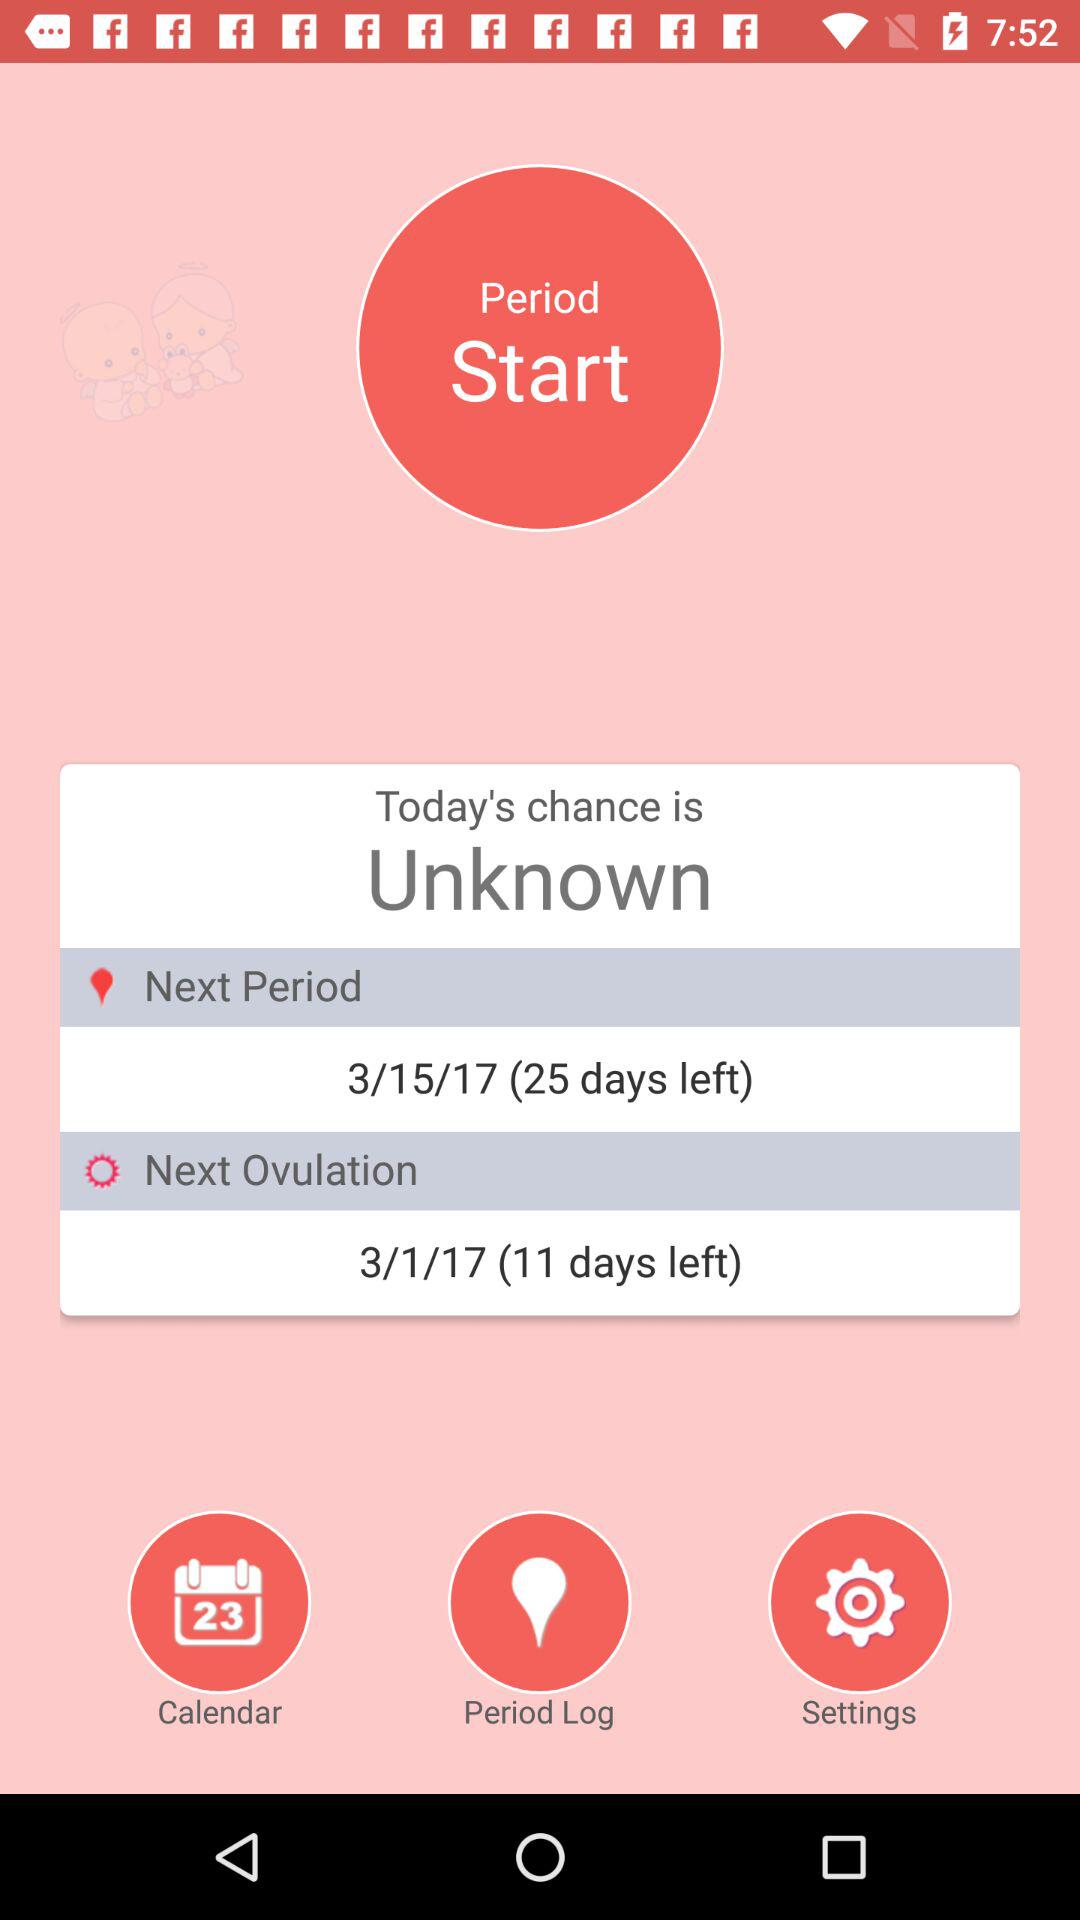What is the date of the next period? The date of the next period is March 15, 2017. 